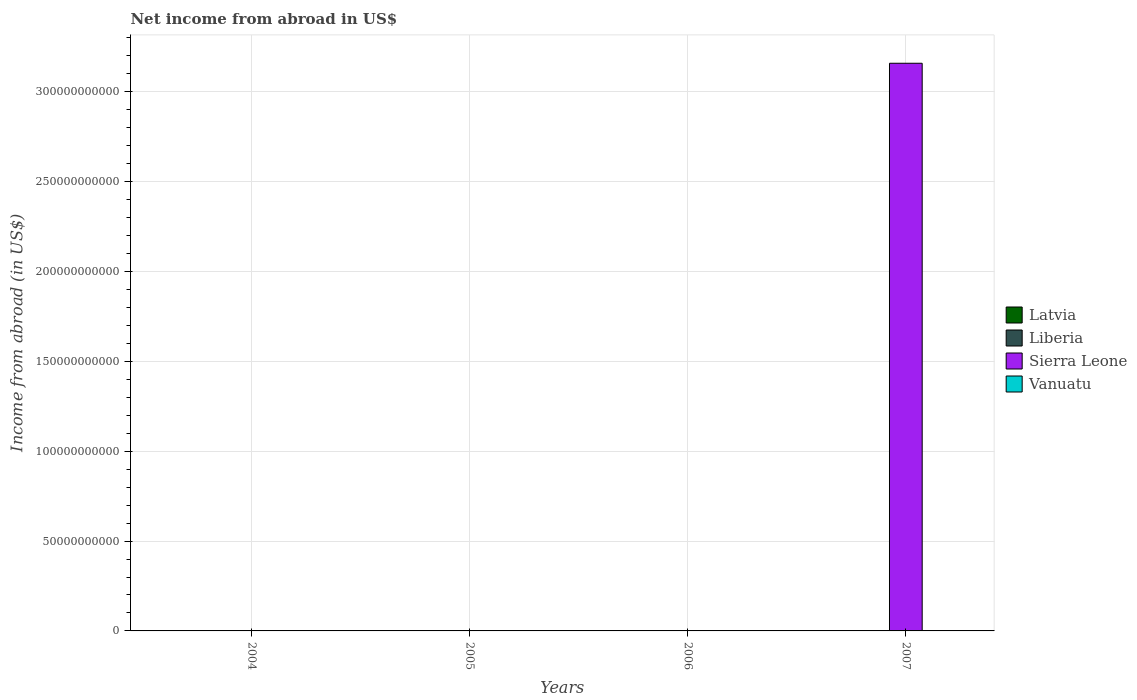Are the number of bars per tick equal to the number of legend labels?
Keep it short and to the point. No. What is the label of the 2nd group of bars from the left?
Your response must be concise. 2005. In how many cases, is the number of bars for a given year not equal to the number of legend labels?
Ensure brevity in your answer.  4. Across all years, what is the maximum net income from abroad in Sierra Leone?
Your response must be concise. 3.16e+11. What is the total net income from abroad in Latvia in the graph?
Make the answer very short. 0. What is the difference between the net income from abroad in Sierra Leone in 2007 and the net income from abroad in Latvia in 2005?
Your answer should be compact. 3.16e+11. What is the average net income from abroad in Sierra Leone per year?
Ensure brevity in your answer.  7.90e+1. How many bars are there?
Your answer should be very brief. 1. Does the graph contain any zero values?
Your response must be concise. Yes. Where does the legend appear in the graph?
Keep it short and to the point. Center right. How many legend labels are there?
Your response must be concise. 4. How are the legend labels stacked?
Offer a terse response. Vertical. What is the title of the graph?
Your response must be concise. Net income from abroad in US$. Does "French Polynesia" appear as one of the legend labels in the graph?
Your response must be concise. No. What is the label or title of the X-axis?
Offer a very short reply. Years. What is the label or title of the Y-axis?
Provide a succinct answer. Income from abroad (in US$). What is the Income from abroad (in US$) in Latvia in 2004?
Give a very brief answer. 0. What is the Income from abroad (in US$) of Vanuatu in 2004?
Give a very brief answer. 0. What is the Income from abroad (in US$) in Liberia in 2005?
Make the answer very short. 0. What is the Income from abroad (in US$) of Sierra Leone in 2005?
Your answer should be compact. 0. What is the Income from abroad (in US$) of Liberia in 2006?
Give a very brief answer. 0. What is the Income from abroad (in US$) in Sierra Leone in 2006?
Give a very brief answer. 0. What is the Income from abroad (in US$) of Vanuatu in 2006?
Offer a terse response. 0. What is the Income from abroad (in US$) of Latvia in 2007?
Ensure brevity in your answer.  0. What is the Income from abroad (in US$) in Liberia in 2007?
Your response must be concise. 0. What is the Income from abroad (in US$) in Sierra Leone in 2007?
Give a very brief answer. 3.16e+11. What is the Income from abroad (in US$) of Vanuatu in 2007?
Provide a short and direct response. 0. Across all years, what is the maximum Income from abroad (in US$) in Sierra Leone?
Your response must be concise. 3.16e+11. Across all years, what is the minimum Income from abroad (in US$) in Sierra Leone?
Your answer should be very brief. 0. What is the total Income from abroad (in US$) in Latvia in the graph?
Your response must be concise. 0. What is the total Income from abroad (in US$) in Sierra Leone in the graph?
Provide a short and direct response. 3.16e+11. What is the average Income from abroad (in US$) in Sierra Leone per year?
Your response must be concise. 7.90e+1. What is the average Income from abroad (in US$) of Vanuatu per year?
Your answer should be compact. 0. What is the difference between the highest and the lowest Income from abroad (in US$) of Sierra Leone?
Provide a short and direct response. 3.16e+11. 